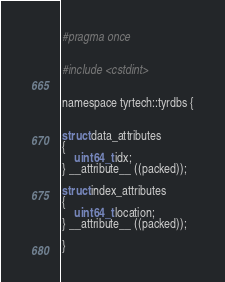Convert code to text. <code><loc_0><loc_0><loc_500><loc_500><_C_>#pragma once


#include <cstdint>


namespace tyrtech::tyrdbs {


struct data_attributes
{
    uint64_t idx;
} __attribute__ ((packed));

struct index_attributes
{
    uint64_t location;
} __attribute__ ((packed));

}
</code> 